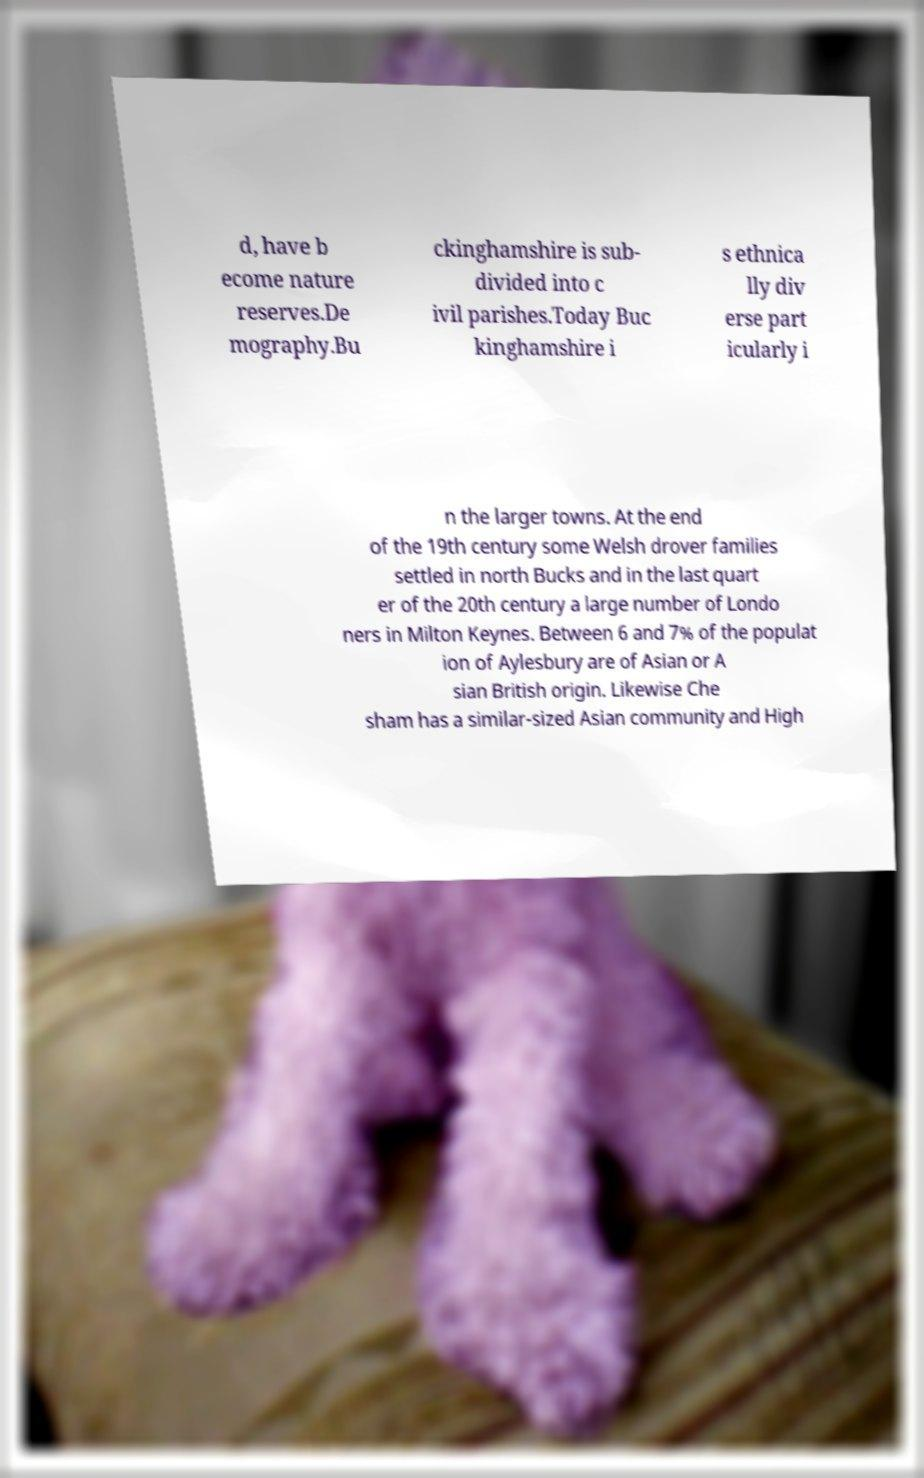What messages or text are displayed in this image? I need them in a readable, typed format. d, have b ecome nature reserves.De mography.Bu ckinghamshire is sub- divided into c ivil parishes.Today Buc kinghamshire i s ethnica lly div erse part icularly i n the larger towns. At the end of the 19th century some Welsh drover families settled in north Bucks and in the last quart er of the 20th century a large number of Londo ners in Milton Keynes. Between 6 and 7% of the populat ion of Aylesbury are of Asian or A sian British origin. Likewise Che sham has a similar-sized Asian community and High 